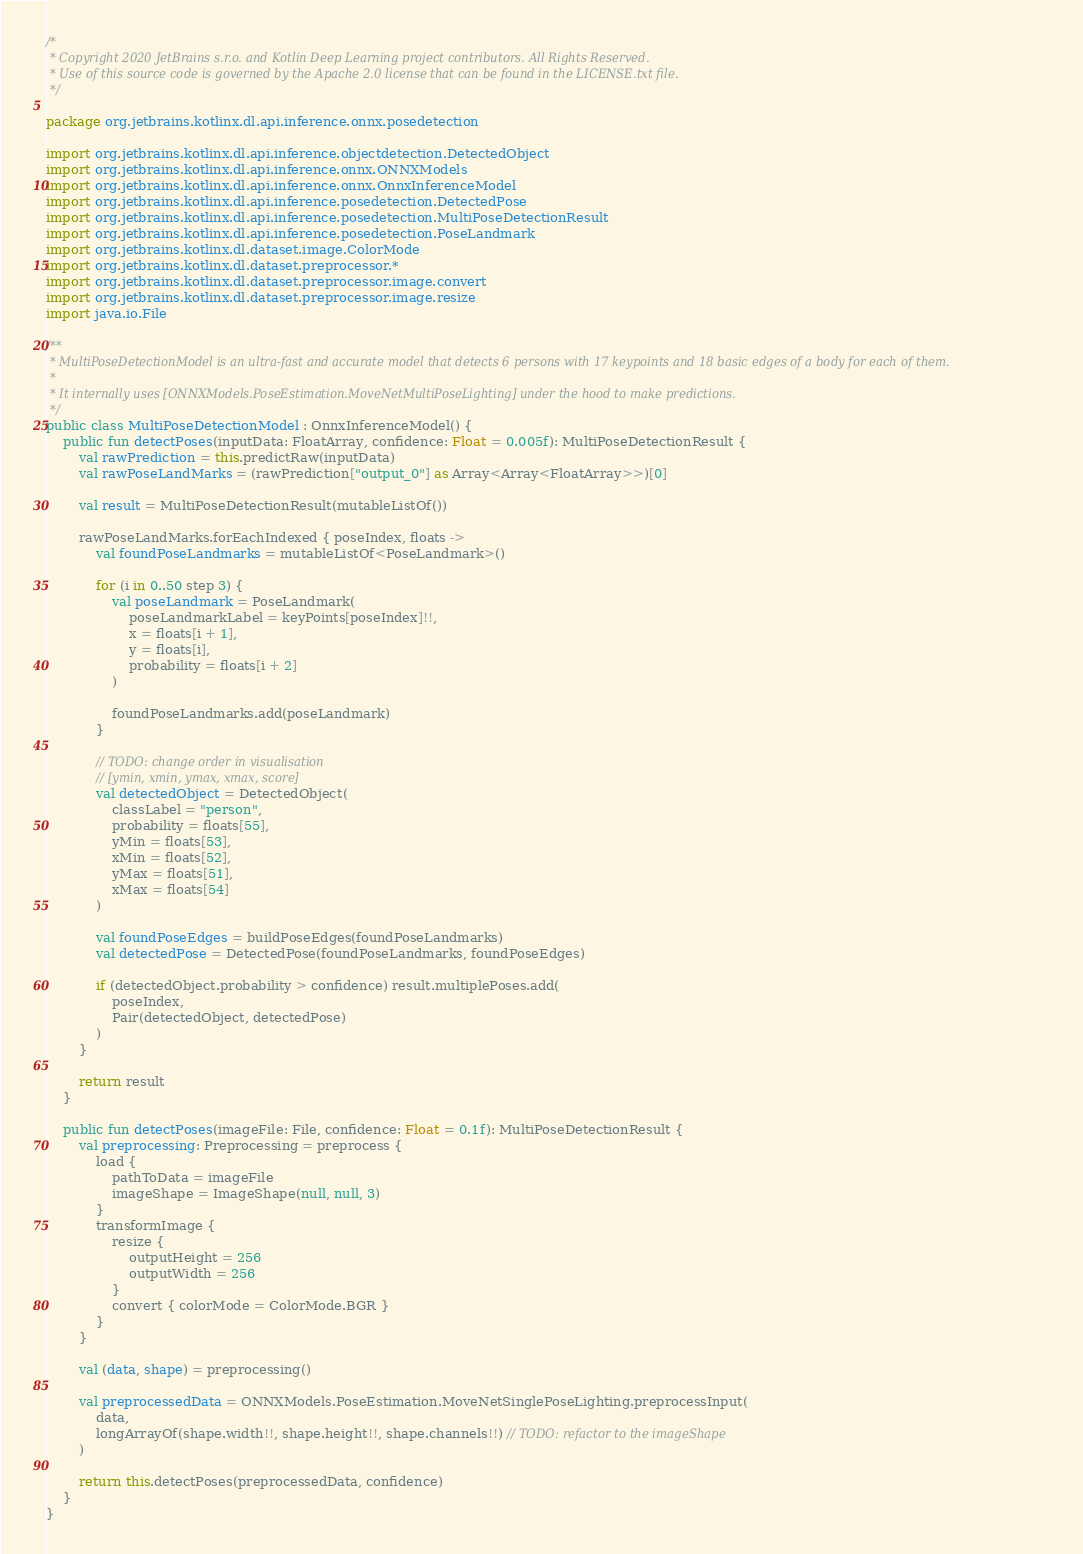<code> <loc_0><loc_0><loc_500><loc_500><_Kotlin_>/*
 * Copyright 2020 JetBrains s.r.o. and Kotlin Deep Learning project contributors. All Rights Reserved.
 * Use of this source code is governed by the Apache 2.0 license that can be found in the LICENSE.txt file.
 */

package org.jetbrains.kotlinx.dl.api.inference.onnx.posedetection

import org.jetbrains.kotlinx.dl.api.inference.objectdetection.DetectedObject
import org.jetbrains.kotlinx.dl.api.inference.onnx.ONNXModels
import org.jetbrains.kotlinx.dl.api.inference.onnx.OnnxInferenceModel
import org.jetbrains.kotlinx.dl.api.inference.posedetection.DetectedPose
import org.jetbrains.kotlinx.dl.api.inference.posedetection.MultiPoseDetectionResult
import org.jetbrains.kotlinx.dl.api.inference.posedetection.PoseLandmark
import org.jetbrains.kotlinx.dl.dataset.image.ColorMode
import org.jetbrains.kotlinx.dl.dataset.preprocessor.*
import org.jetbrains.kotlinx.dl.dataset.preprocessor.image.convert
import org.jetbrains.kotlinx.dl.dataset.preprocessor.image.resize
import java.io.File

/**
 * MultiPoseDetectionModel is an ultra-fast and accurate model that detects 6 persons with 17 keypoints and 18 basic edges of a body for each of them.
 *
 * It internally uses [ONNXModels.PoseEstimation.MoveNetMultiPoseLighting] under the hood to make predictions.
 */
public class MultiPoseDetectionModel : OnnxInferenceModel() {
    public fun detectPoses(inputData: FloatArray, confidence: Float = 0.005f): MultiPoseDetectionResult {
        val rawPrediction = this.predictRaw(inputData)
        val rawPoseLandMarks = (rawPrediction["output_0"] as Array<Array<FloatArray>>)[0]

        val result = MultiPoseDetectionResult(mutableListOf())

        rawPoseLandMarks.forEachIndexed { poseIndex, floats ->
            val foundPoseLandmarks = mutableListOf<PoseLandmark>()

            for (i in 0..50 step 3) {
                val poseLandmark = PoseLandmark(
                    poseLandmarkLabel = keyPoints[poseIndex]!!,
                    x = floats[i + 1],
                    y = floats[i],
                    probability = floats[i + 2]
                )

                foundPoseLandmarks.add(poseLandmark)
            }

            // TODO: change order in visualisation
            // [ymin, xmin, ymax, xmax, score]
            val detectedObject = DetectedObject(
                classLabel = "person",
                probability = floats[55],
                yMin = floats[53],
                xMin = floats[52],
                yMax = floats[51],
                xMax = floats[54]
            )

            val foundPoseEdges = buildPoseEdges(foundPoseLandmarks)
            val detectedPose = DetectedPose(foundPoseLandmarks, foundPoseEdges)

            if (detectedObject.probability > confidence) result.multiplePoses.add(
                poseIndex,
                Pair(detectedObject, detectedPose)
            )
        }

        return result
    }

    public fun detectPoses(imageFile: File, confidence: Float = 0.1f): MultiPoseDetectionResult {
        val preprocessing: Preprocessing = preprocess {
            load {
                pathToData = imageFile
                imageShape = ImageShape(null, null, 3)
            }
            transformImage {
                resize {
                    outputHeight = 256
                    outputWidth = 256
                }
                convert { colorMode = ColorMode.BGR }
            }
        }

        val (data, shape) = preprocessing()

        val preprocessedData = ONNXModels.PoseEstimation.MoveNetSinglePoseLighting.preprocessInput(
            data,
            longArrayOf(shape.width!!, shape.height!!, shape.channels!!) // TODO: refactor to the imageShape
        )

        return this.detectPoses(preprocessedData, confidence)
    }
}
</code> 